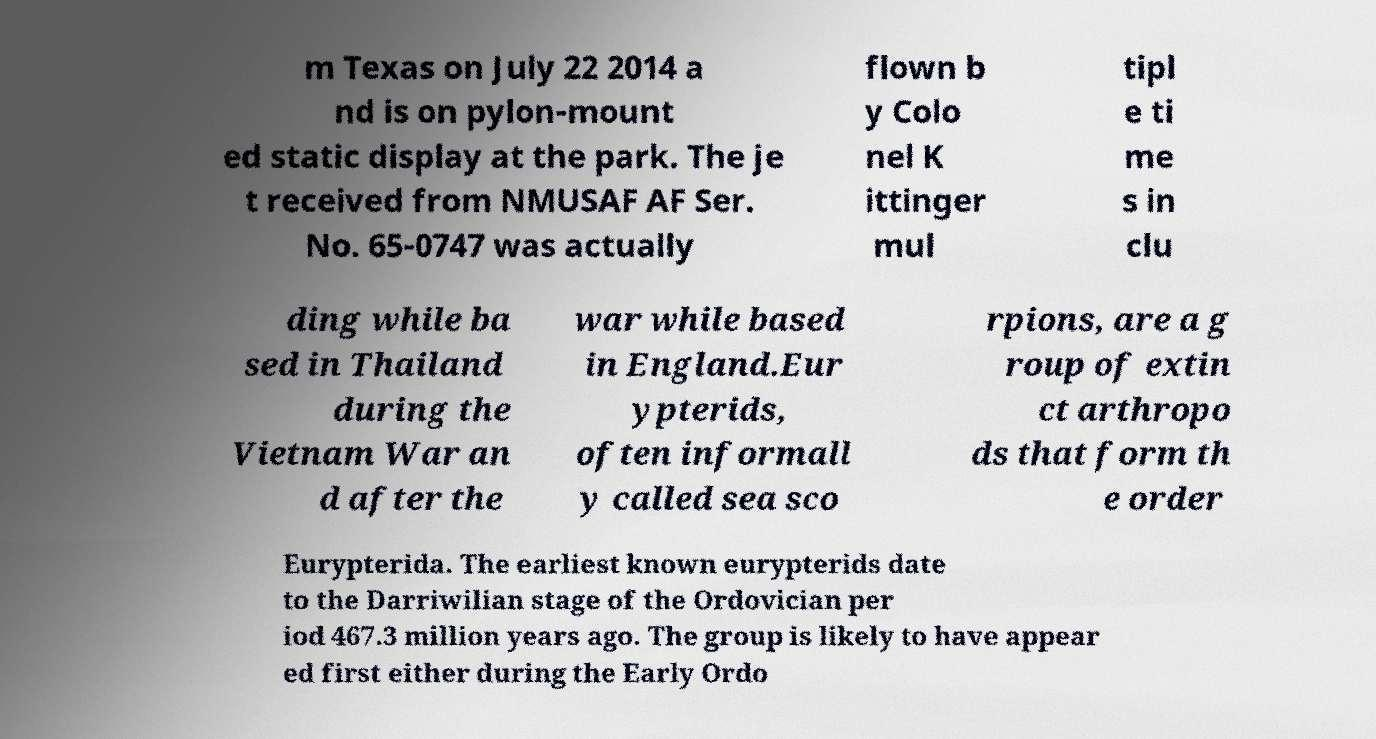For documentation purposes, I need the text within this image transcribed. Could you provide that? m Texas on July 22 2014 a nd is on pylon-mount ed static display at the park. The je t received from NMUSAF AF Ser. No. 65-0747 was actually flown b y Colo nel K ittinger mul tipl e ti me s in clu ding while ba sed in Thailand during the Vietnam War an d after the war while based in England.Eur ypterids, often informall y called sea sco rpions, are a g roup of extin ct arthropo ds that form th e order Eurypterida. The earliest known eurypterids date to the Darriwilian stage of the Ordovician per iod 467.3 million years ago. The group is likely to have appear ed first either during the Early Ordo 